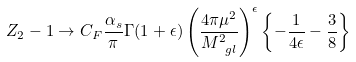<formula> <loc_0><loc_0><loc_500><loc_500>Z _ { 2 } - 1 \to C _ { F } \frac { \alpha _ { s } } { \pi } \Gamma ( 1 + \epsilon ) \left ( \frac { 4 \pi \mu ^ { 2 } } { M _ { \ g l } ^ { 2 } } \right ) ^ { \epsilon } \left \{ - \frac { 1 } { 4 \epsilon } - \frac { 3 } { 8 } \right \}</formula> 